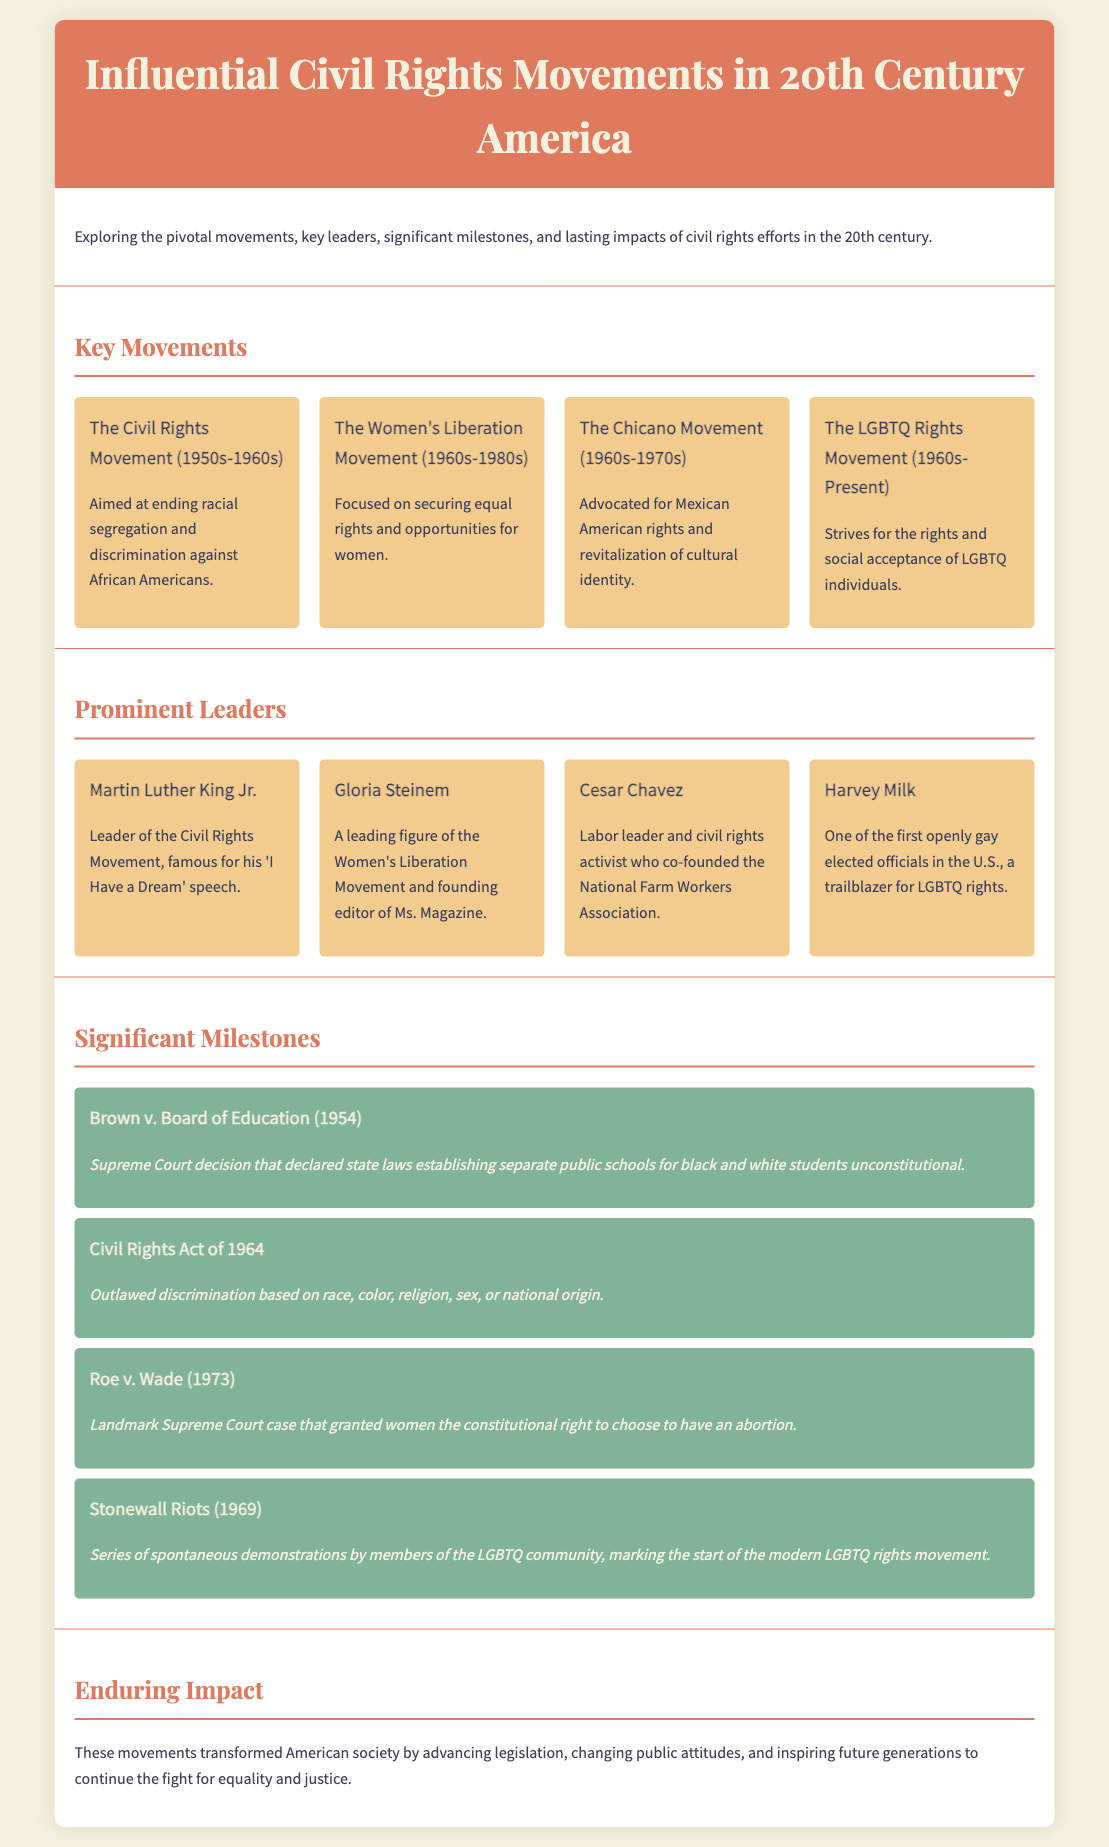What is the focus of the Civil Rights Movement? The Civil Rights Movement aimed at ending racial segregation and discrimination against African Americans.
Answer: Ending racial segregation Who was a leading figure of the Women's Liberation Movement? Gloria Steinem is noted as a leading figure of the Women's Liberation Movement and founding editor of Ms. Magazine.
Answer: Gloria Steinem What significant Supreme Court case was decided in 1954? Brown v. Board of Education is the significant Supreme Court case decided in 1954, declaring separate public schools unconstitutional.
Answer: Brown v. Board of Education Which event marked the start of the modern LGBTQ rights movement? The Stonewall Riots in 1969 are recognized as marking the start of the modern LGBTQ rights movement.
Answer: Stonewall Riots What landmark legislation was passed in 1964? The Civil Rights Act of 1964 outlawed discrimination based on several factors including race and sex.
Answer: Civil Rights Act of 1964 How many movements are listed in the infographic? The infographic lists four key movements in the section provided.
Answer: Four Which leader is known for the 'I Have a Dream' speech? Martin Luther King Jr. is famously known for his 'I Have a Dream' speech during the Civil Rights Movement.
Answer: Martin Luther King Jr What was the impact of Roe v. Wade? Roe v. Wade granted women the constitutional right to choose to have an abortion.
Answer: Constitutional right to choose an abortion Who co-founded the National Farm Workers Association? Cesar Chavez co-founded the National Farm Workers Association as a labor leader and civil rights activist.
Answer: Cesar Chavez 